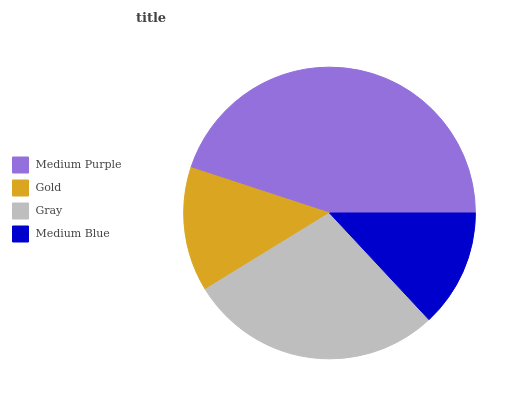Is Medium Blue the minimum?
Answer yes or no. Yes. Is Medium Purple the maximum?
Answer yes or no. Yes. Is Gold the minimum?
Answer yes or no. No. Is Gold the maximum?
Answer yes or no. No. Is Medium Purple greater than Gold?
Answer yes or no. Yes. Is Gold less than Medium Purple?
Answer yes or no. Yes. Is Gold greater than Medium Purple?
Answer yes or no. No. Is Medium Purple less than Gold?
Answer yes or no. No. Is Gray the high median?
Answer yes or no. Yes. Is Gold the low median?
Answer yes or no. Yes. Is Medium Blue the high median?
Answer yes or no. No. Is Gray the low median?
Answer yes or no. No. 